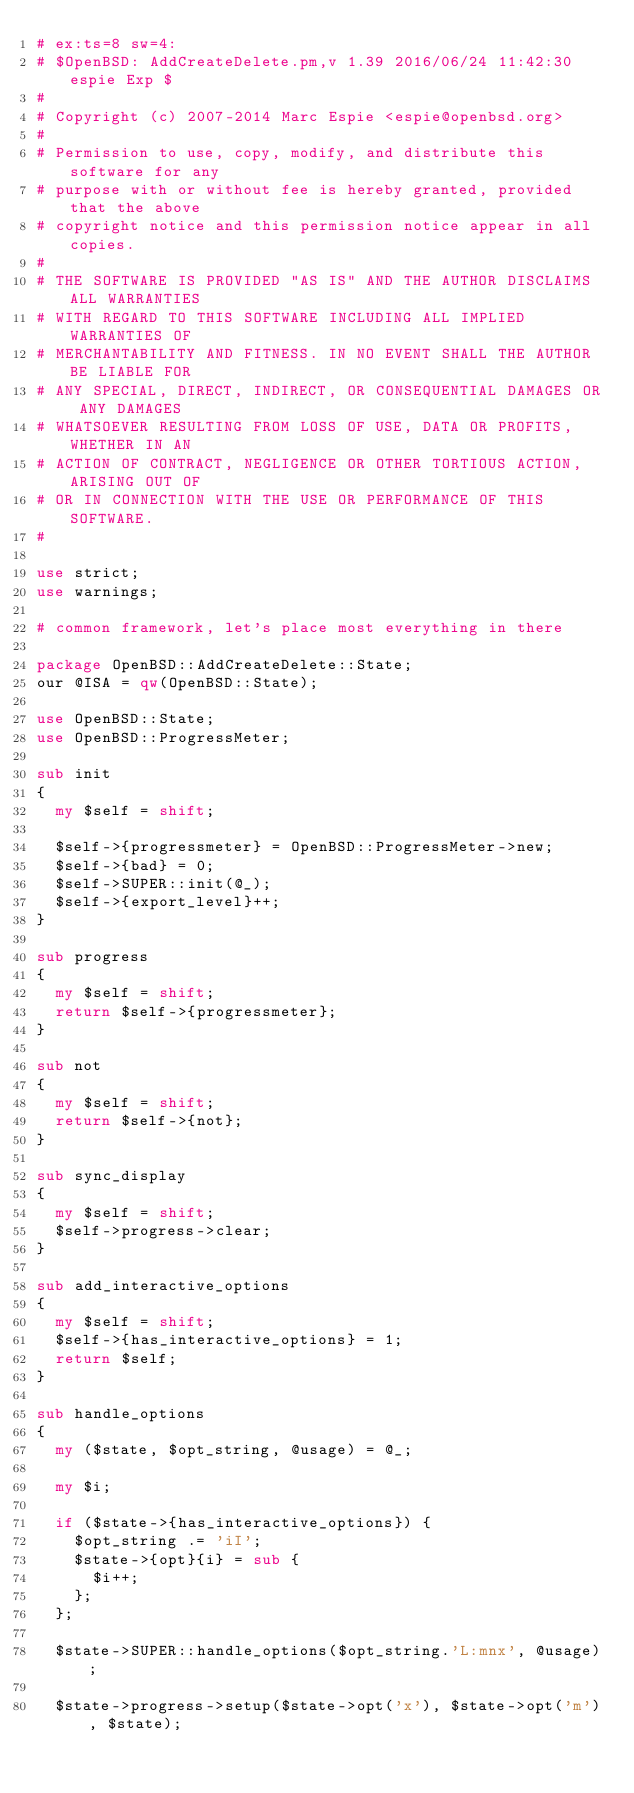<code> <loc_0><loc_0><loc_500><loc_500><_Perl_># ex:ts=8 sw=4:
# $OpenBSD: AddCreateDelete.pm,v 1.39 2016/06/24 11:42:30 espie Exp $
#
# Copyright (c) 2007-2014 Marc Espie <espie@openbsd.org>
#
# Permission to use, copy, modify, and distribute this software for any
# purpose with or without fee is hereby granted, provided that the above
# copyright notice and this permission notice appear in all copies.
#
# THE SOFTWARE IS PROVIDED "AS IS" AND THE AUTHOR DISCLAIMS ALL WARRANTIES
# WITH REGARD TO THIS SOFTWARE INCLUDING ALL IMPLIED WARRANTIES OF
# MERCHANTABILITY AND FITNESS. IN NO EVENT SHALL THE AUTHOR BE LIABLE FOR
# ANY SPECIAL, DIRECT, INDIRECT, OR CONSEQUENTIAL DAMAGES OR ANY DAMAGES
# WHATSOEVER RESULTING FROM LOSS OF USE, DATA OR PROFITS, WHETHER IN AN
# ACTION OF CONTRACT, NEGLIGENCE OR OTHER TORTIOUS ACTION, ARISING OUT OF
# OR IN CONNECTION WITH THE USE OR PERFORMANCE OF THIS SOFTWARE.
#

use strict;
use warnings;

# common framework, let's place most everything in there

package OpenBSD::AddCreateDelete::State;
our @ISA = qw(OpenBSD::State);

use OpenBSD::State;
use OpenBSD::ProgressMeter;

sub init
{
	my $self = shift;

	$self->{progressmeter} = OpenBSD::ProgressMeter->new;
	$self->{bad} = 0;
	$self->SUPER::init(@_);
	$self->{export_level}++;
}

sub progress
{
	my $self = shift;
	return $self->{progressmeter};
}

sub not
{
	my $self = shift;
	return $self->{not};
}

sub sync_display
{
	my $self = shift;
	$self->progress->clear;
}

sub add_interactive_options
{
	my $self = shift;
	$self->{has_interactive_options} = 1;
	return $self;
}

sub handle_options
{
	my ($state, $opt_string, @usage) = @_;

	my $i;

	if ($state->{has_interactive_options}) {
		$opt_string .= 'iI';
		$state->{opt}{i} = sub {
			$i++;
		};
	};

	$state->SUPER::handle_options($opt_string.'L:mnx', @usage);

	$state->progress->setup($state->opt('x'), $state->opt('m'), $state);</code> 